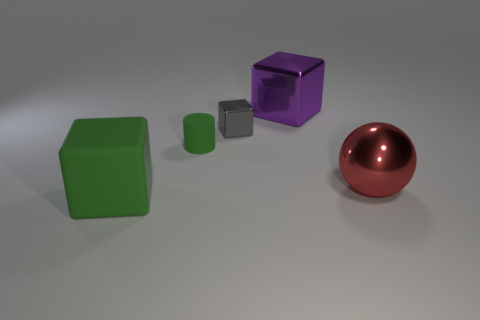Subtract all metal blocks. How many blocks are left? 1 Subtract all green blocks. How many blocks are left? 2 Add 1 purple cubes. How many objects exist? 6 Subtract 1 blocks. How many blocks are left? 2 Subtract all cylinders. How many objects are left? 4 Add 1 big red shiny spheres. How many big red shiny spheres are left? 2 Add 5 large blue metallic things. How many large blue metallic things exist? 5 Subtract 0 red blocks. How many objects are left? 5 Subtract all blue cubes. Subtract all blue cylinders. How many cubes are left? 3 Subtract all green cubes. How many cyan balls are left? 0 